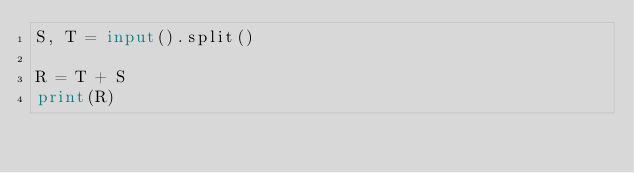Convert code to text. <code><loc_0><loc_0><loc_500><loc_500><_Python_>S, T = input().split()

R = T + S
print(R)</code> 